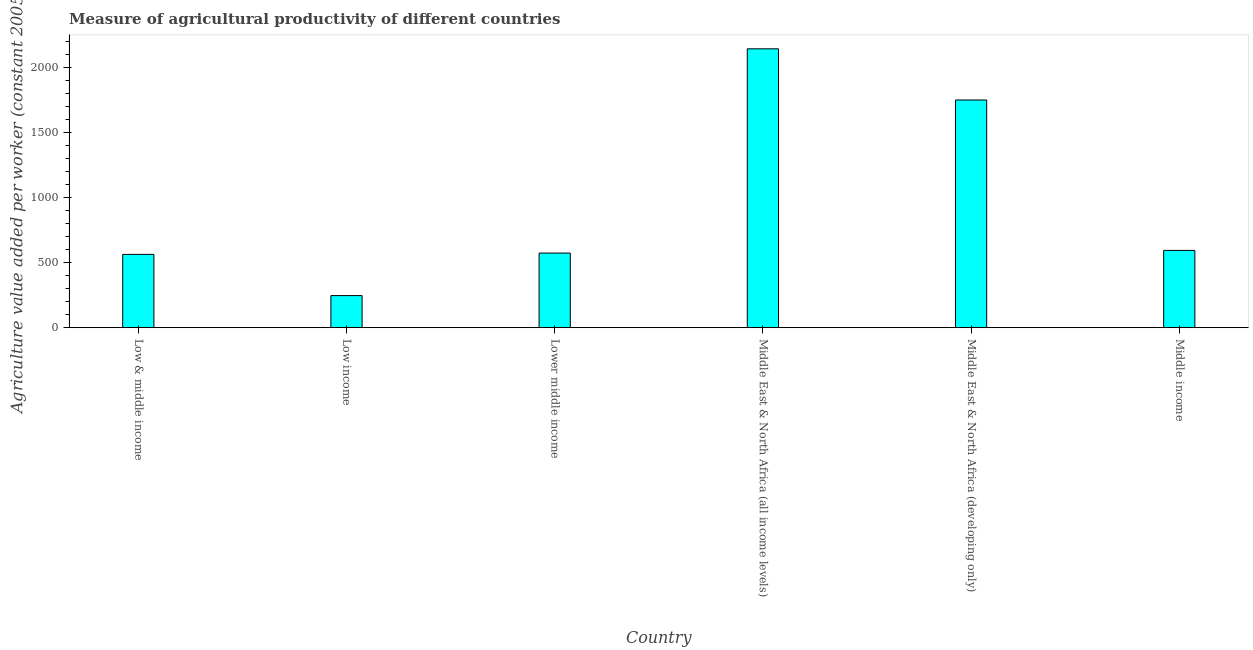Does the graph contain any zero values?
Your answer should be compact. No. What is the title of the graph?
Keep it short and to the point. Measure of agricultural productivity of different countries. What is the label or title of the X-axis?
Your response must be concise. Country. What is the label or title of the Y-axis?
Keep it short and to the point. Agriculture value added per worker (constant 2005 US$). What is the agriculture value added per worker in Lower middle income?
Your response must be concise. 573.91. Across all countries, what is the maximum agriculture value added per worker?
Provide a short and direct response. 2145.38. Across all countries, what is the minimum agriculture value added per worker?
Offer a very short reply. 246.73. In which country was the agriculture value added per worker maximum?
Ensure brevity in your answer.  Middle East & North Africa (all income levels). What is the sum of the agriculture value added per worker?
Your response must be concise. 5875.79. What is the difference between the agriculture value added per worker in Low income and Middle East & North Africa (developing only)?
Keep it short and to the point. -1504.91. What is the average agriculture value added per worker per country?
Give a very brief answer. 979.3. What is the median agriculture value added per worker?
Your answer should be compact. 584.11. In how many countries, is the agriculture value added per worker greater than 400 US$?
Provide a short and direct response. 5. What is the ratio of the agriculture value added per worker in Lower middle income to that in Middle East & North Africa (developing only)?
Offer a very short reply. 0.33. Is the difference between the agriculture value added per worker in Low & middle income and Low income greater than the difference between any two countries?
Ensure brevity in your answer.  No. What is the difference between the highest and the second highest agriculture value added per worker?
Offer a terse response. 393.74. What is the difference between the highest and the lowest agriculture value added per worker?
Your answer should be compact. 1898.65. In how many countries, is the agriculture value added per worker greater than the average agriculture value added per worker taken over all countries?
Your answer should be compact. 2. How many countries are there in the graph?
Provide a short and direct response. 6. What is the difference between two consecutive major ticks on the Y-axis?
Keep it short and to the point. 500. What is the Agriculture value added per worker (constant 2005 US$) of Low & middle income?
Give a very brief answer. 563.84. What is the Agriculture value added per worker (constant 2005 US$) of Low income?
Ensure brevity in your answer.  246.73. What is the Agriculture value added per worker (constant 2005 US$) in Lower middle income?
Your answer should be very brief. 573.91. What is the Agriculture value added per worker (constant 2005 US$) in Middle East & North Africa (all income levels)?
Make the answer very short. 2145.38. What is the Agriculture value added per worker (constant 2005 US$) of Middle East & North Africa (developing only)?
Ensure brevity in your answer.  1751.64. What is the Agriculture value added per worker (constant 2005 US$) in Middle income?
Offer a terse response. 594.31. What is the difference between the Agriculture value added per worker (constant 2005 US$) in Low & middle income and Low income?
Ensure brevity in your answer.  317.11. What is the difference between the Agriculture value added per worker (constant 2005 US$) in Low & middle income and Lower middle income?
Offer a terse response. -10.07. What is the difference between the Agriculture value added per worker (constant 2005 US$) in Low & middle income and Middle East & North Africa (all income levels)?
Keep it short and to the point. -1581.54. What is the difference between the Agriculture value added per worker (constant 2005 US$) in Low & middle income and Middle East & North Africa (developing only)?
Offer a terse response. -1187.8. What is the difference between the Agriculture value added per worker (constant 2005 US$) in Low & middle income and Middle income?
Offer a very short reply. -30.47. What is the difference between the Agriculture value added per worker (constant 2005 US$) in Low income and Lower middle income?
Keep it short and to the point. -327.18. What is the difference between the Agriculture value added per worker (constant 2005 US$) in Low income and Middle East & North Africa (all income levels)?
Your answer should be very brief. -1898.65. What is the difference between the Agriculture value added per worker (constant 2005 US$) in Low income and Middle East & North Africa (developing only)?
Offer a terse response. -1504.91. What is the difference between the Agriculture value added per worker (constant 2005 US$) in Low income and Middle income?
Make the answer very short. -347.58. What is the difference between the Agriculture value added per worker (constant 2005 US$) in Lower middle income and Middle East & North Africa (all income levels)?
Your answer should be compact. -1571.47. What is the difference between the Agriculture value added per worker (constant 2005 US$) in Lower middle income and Middle East & North Africa (developing only)?
Your answer should be very brief. -1177.73. What is the difference between the Agriculture value added per worker (constant 2005 US$) in Lower middle income and Middle income?
Offer a terse response. -20.41. What is the difference between the Agriculture value added per worker (constant 2005 US$) in Middle East & North Africa (all income levels) and Middle East & North Africa (developing only)?
Make the answer very short. 393.74. What is the difference between the Agriculture value added per worker (constant 2005 US$) in Middle East & North Africa (all income levels) and Middle income?
Make the answer very short. 1551.06. What is the difference between the Agriculture value added per worker (constant 2005 US$) in Middle East & North Africa (developing only) and Middle income?
Provide a succinct answer. 1157.33. What is the ratio of the Agriculture value added per worker (constant 2005 US$) in Low & middle income to that in Low income?
Provide a succinct answer. 2.29. What is the ratio of the Agriculture value added per worker (constant 2005 US$) in Low & middle income to that in Lower middle income?
Give a very brief answer. 0.98. What is the ratio of the Agriculture value added per worker (constant 2005 US$) in Low & middle income to that in Middle East & North Africa (all income levels)?
Give a very brief answer. 0.26. What is the ratio of the Agriculture value added per worker (constant 2005 US$) in Low & middle income to that in Middle East & North Africa (developing only)?
Make the answer very short. 0.32. What is the ratio of the Agriculture value added per worker (constant 2005 US$) in Low & middle income to that in Middle income?
Your answer should be very brief. 0.95. What is the ratio of the Agriculture value added per worker (constant 2005 US$) in Low income to that in Lower middle income?
Your answer should be compact. 0.43. What is the ratio of the Agriculture value added per worker (constant 2005 US$) in Low income to that in Middle East & North Africa (all income levels)?
Keep it short and to the point. 0.12. What is the ratio of the Agriculture value added per worker (constant 2005 US$) in Low income to that in Middle East & North Africa (developing only)?
Provide a short and direct response. 0.14. What is the ratio of the Agriculture value added per worker (constant 2005 US$) in Low income to that in Middle income?
Your response must be concise. 0.41. What is the ratio of the Agriculture value added per worker (constant 2005 US$) in Lower middle income to that in Middle East & North Africa (all income levels)?
Ensure brevity in your answer.  0.27. What is the ratio of the Agriculture value added per worker (constant 2005 US$) in Lower middle income to that in Middle East & North Africa (developing only)?
Make the answer very short. 0.33. What is the ratio of the Agriculture value added per worker (constant 2005 US$) in Middle East & North Africa (all income levels) to that in Middle East & North Africa (developing only)?
Provide a succinct answer. 1.23. What is the ratio of the Agriculture value added per worker (constant 2005 US$) in Middle East & North Africa (all income levels) to that in Middle income?
Provide a succinct answer. 3.61. What is the ratio of the Agriculture value added per worker (constant 2005 US$) in Middle East & North Africa (developing only) to that in Middle income?
Give a very brief answer. 2.95. 